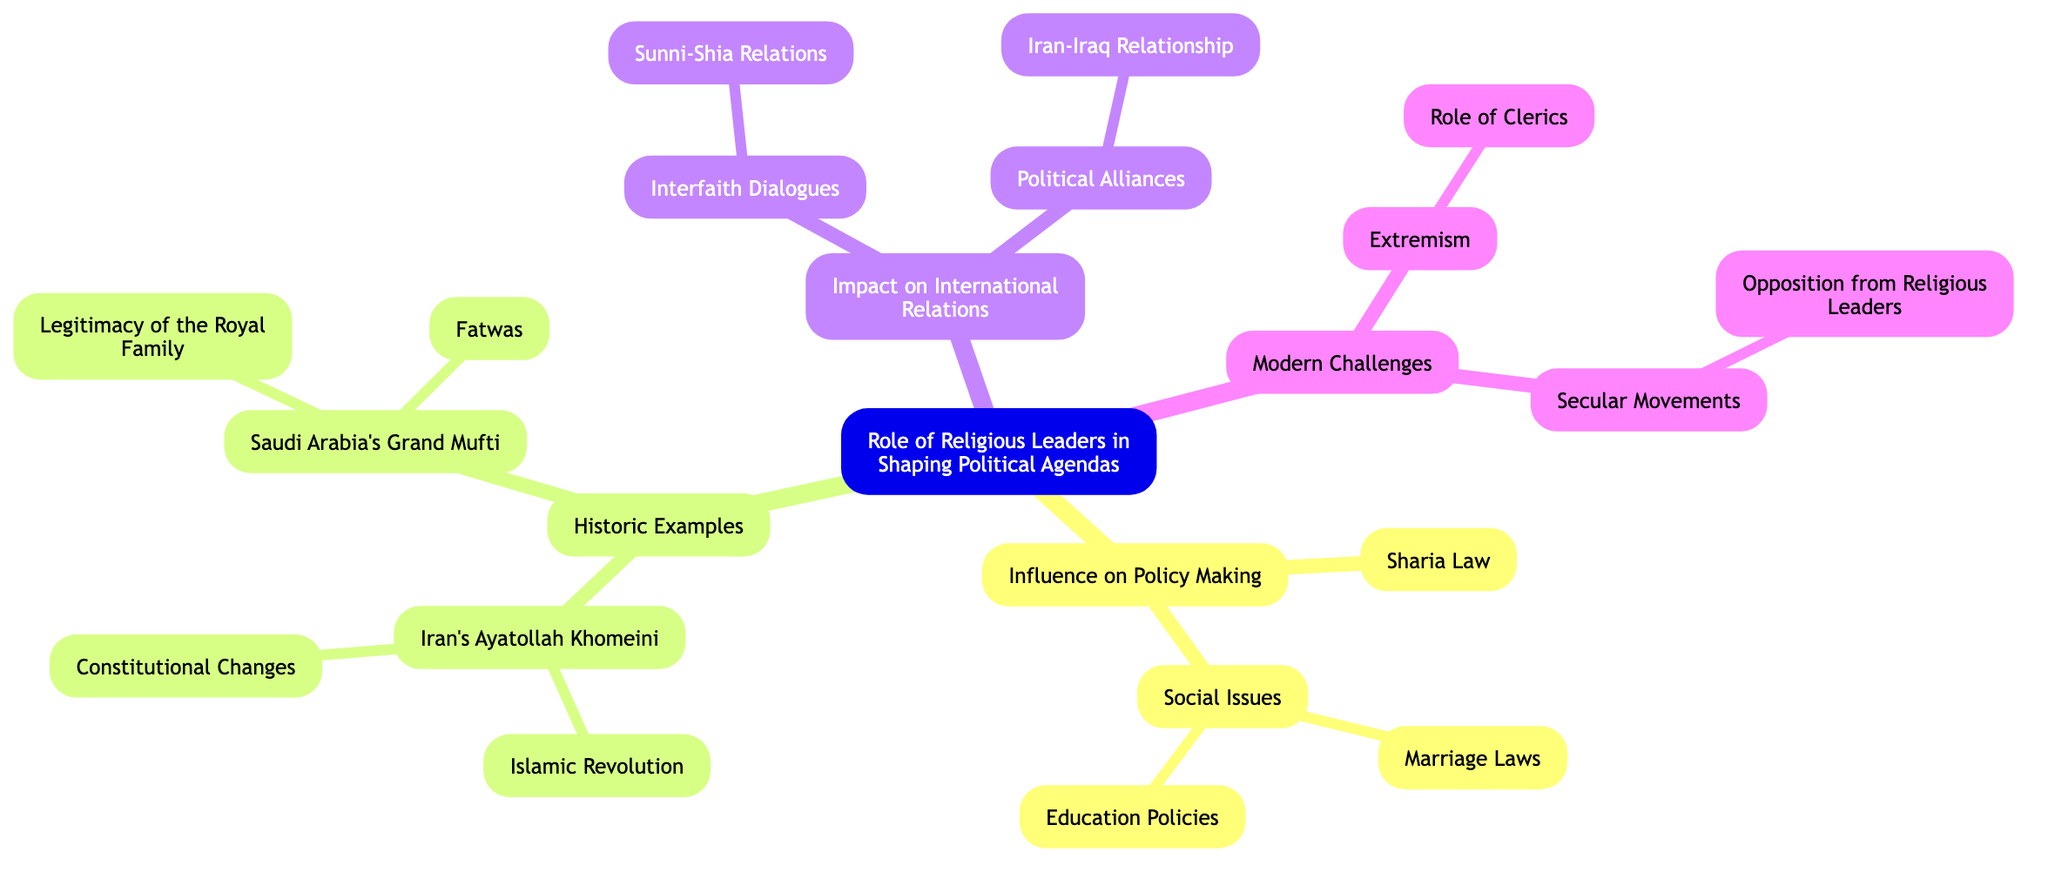What are the main areas of influence for religious leaders? The main areas of influence listed in the diagram are "Influence on Policy Making", "Historic Examples", "Impact on International Relations", and "Modern Challenges". These are the primary branches stemming from the central idea.
Answer: Influence on Policy Making, Historic Examples, Impact on International Relations, Modern Challenges Which historical figure is associated with the Islamic Revolution? The diagram indicates that Iran's Ayatollah Khomeini is associated with the Islamic Revolution as one of the sub-branches under historic examples.
Answer: Iran's Ayatollah Khomeini How many sub-branches are under "Social Issues"? Under the "Social Issues" branch, there are two sub-branches: "Marriage Laws" and "Education Policies", making a total of two sub-branches.
Answer: 2 What role do clerics play in modern challenges according to the diagram? The diagram lists "Role of Clerics" as a sub-branch under "Extremism", indicating that clerics are involved in issues related to extremism in modern challenges.
Answer: Role of Clerics What does the "Interfaith Dialogues" branch address? The "Interfaith Dialogues" branch includes a sub-branch focusing on "Sunni-Shia Relations", highlighting its role in discussions among different Islamic sects.
Answer: Sunni-Shia Relations Which country's religious leader is linked to the legitimacy of the royal family? The Saudi Arabia's Grand Mufti is linked to the "Legitimacy of the Royal Family" according to the diagram, indicating this relationship under historic examples.
Answer: Saudi Arabia's Grand Mufti What are the two reasons for opposition from religious leaders in secular movements? The diagram does not specify two reasons but indicates a single reason for opposition from religious leaders under "Secular Movements", which is named "Opposition from Religious Leaders".
Answer: Opposition from Religious Leaders How does the "Iran-Iraq Relationship" fit into the diagram? The "Iran-Iraq Relationship" is noted under "Political Alliances" within the "Impact on International Relations" section, linking it to the geopolitical dynamics affected by religious leaders.
Answer: Iran-Iraq Relationship 